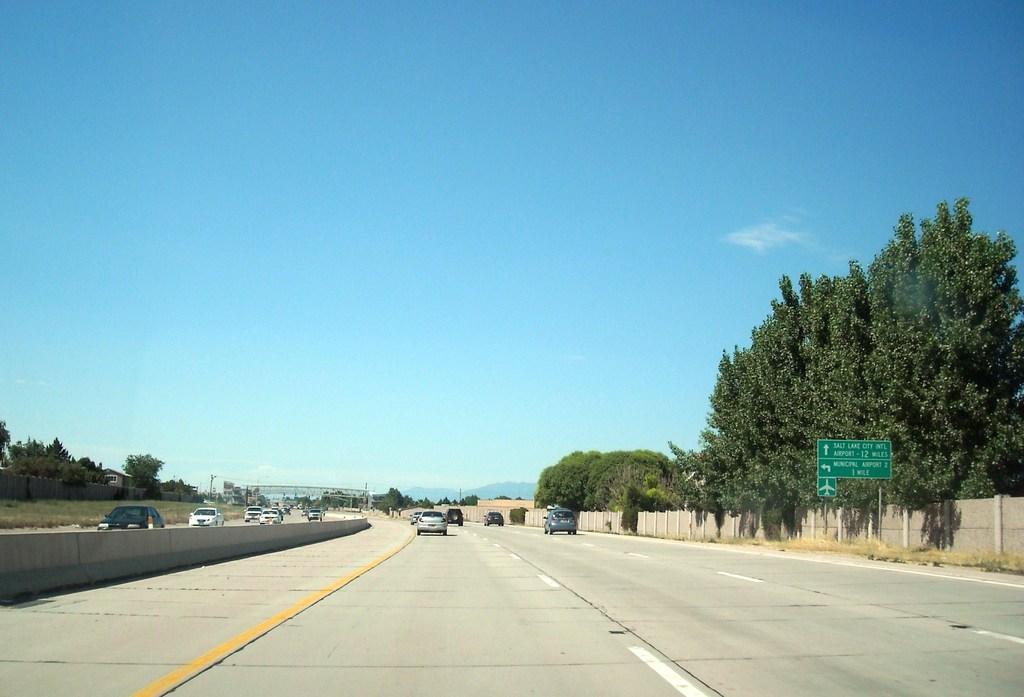Describe this image in one or two sentences. In this image there is a highway in the middle. On the highway there are so many vehicles. There are trees on either side of the road. On the right side there is a wooden fence beside the road. There is a direction board which is kept on the sidewalk. At the top there is the sky. 